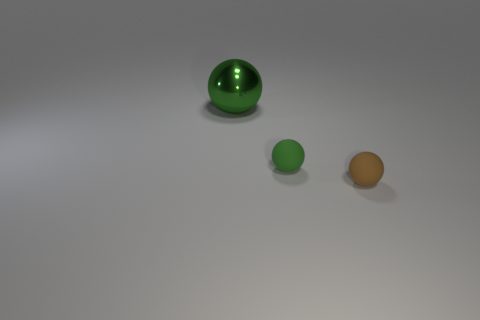Subtract all big spheres. How many spheres are left? 2 Add 2 shiny spheres. How many objects exist? 5 Subtract all green spheres. How many spheres are left? 1 Subtract 1 spheres. How many spheres are left? 2 Add 2 green shiny spheres. How many green shiny spheres exist? 3 Subtract 0 blue blocks. How many objects are left? 3 Subtract all yellow balls. Subtract all purple cubes. How many balls are left? 3 Subtract all yellow cubes. How many cyan spheres are left? 0 Subtract all gray rubber spheres. Subtract all large green metal objects. How many objects are left? 2 Add 3 small green things. How many small green things are left? 4 